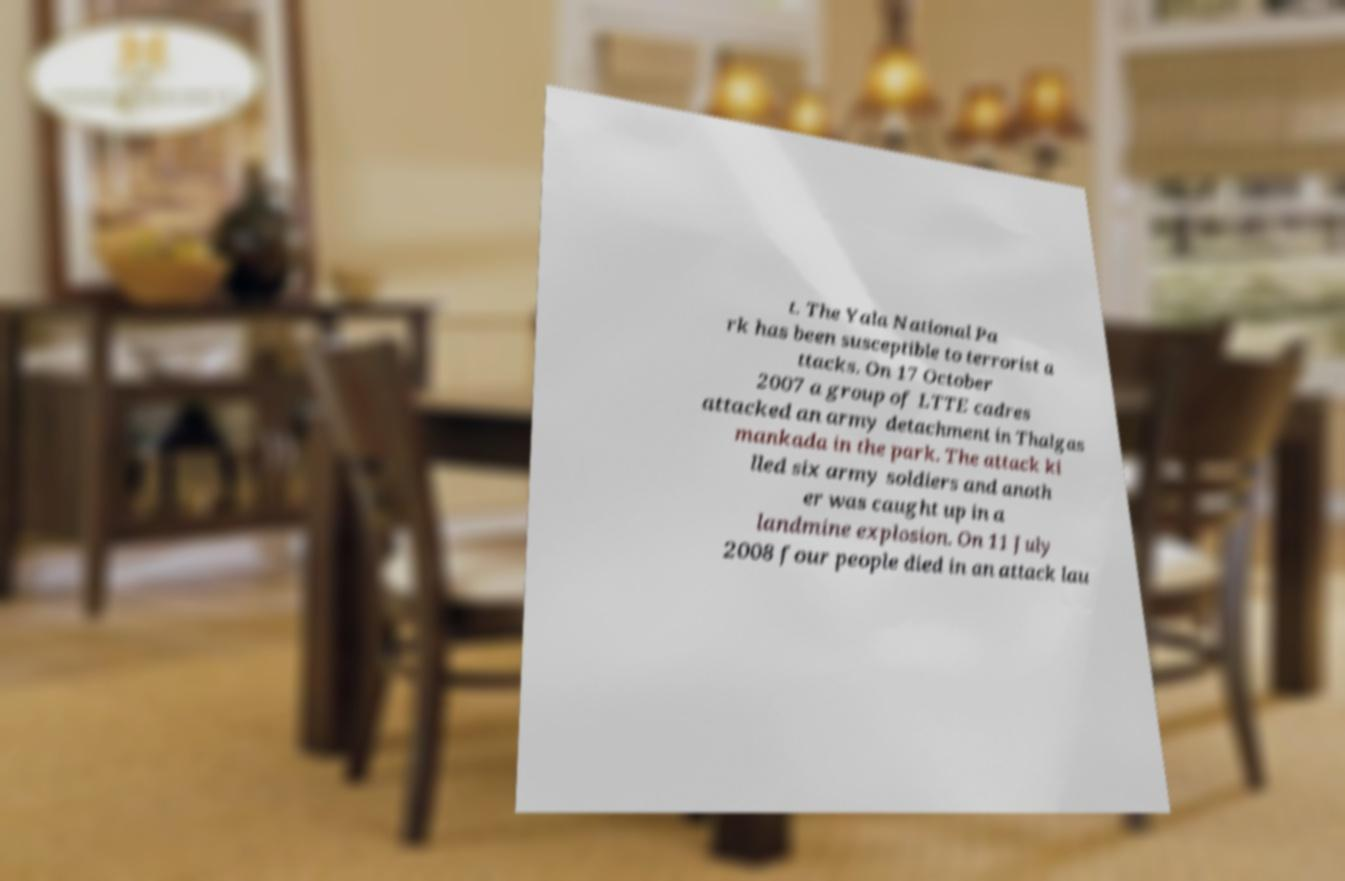Could you assist in decoding the text presented in this image and type it out clearly? t. The Yala National Pa rk has been susceptible to terrorist a ttacks. On 17 October 2007 a group of LTTE cadres attacked an army detachment in Thalgas mankada in the park. The attack ki lled six army soldiers and anoth er was caught up in a landmine explosion. On 11 July 2008 four people died in an attack lau 